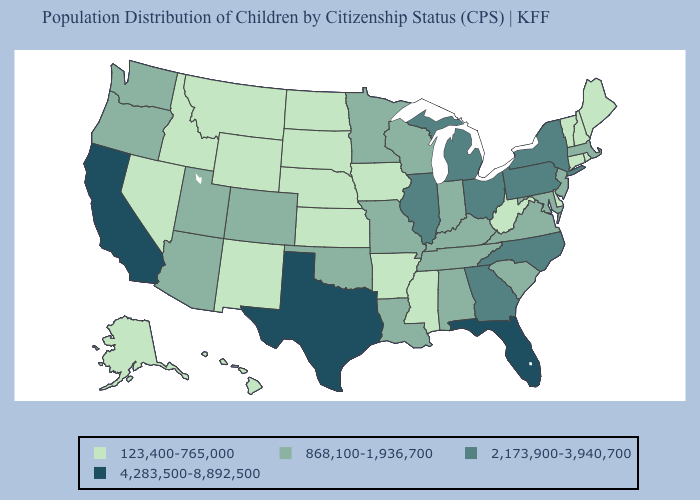Name the states that have a value in the range 4,283,500-8,892,500?
Answer briefly. California, Florida, Texas. What is the lowest value in the MidWest?
Concise answer only. 123,400-765,000. Which states have the lowest value in the West?
Be succinct. Alaska, Hawaii, Idaho, Montana, Nevada, New Mexico, Wyoming. What is the lowest value in states that border Mississippi?
Give a very brief answer. 123,400-765,000. Does Illinois have the highest value in the MidWest?
Keep it brief. Yes. What is the value of Hawaii?
Keep it brief. 123,400-765,000. What is the lowest value in the MidWest?
Give a very brief answer. 123,400-765,000. Does Montana have the lowest value in the USA?
Give a very brief answer. Yes. Does South Carolina have a lower value than Tennessee?
Answer briefly. No. Does New Jersey have the lowest value in the USA?
Quick response, please. No. What is the value of Ohio?
Concise answer only. 2,173,900-3,940,700. What is the lowest value in the Northeast?
Quick response, please. 123,400-765,000. What is the value of Kansas?
Short answer required. 123,400-765,000. Name the states that have a value in the range 2,173,900-3,940,700?
Give a very brief answer. Georgia, Illinois, Michigan, New York, North Carolina, Ohio, Pennsylvania. What is the value of Ohio?
Be succinct. 2,173,900-3,940,700. 